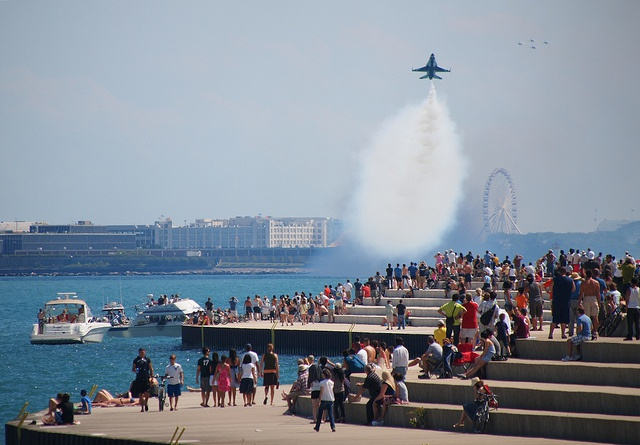Describe the objects in this image and their specific colors. I can see people in darkgray, black, gray, and maroon tones, boat in darkgray, gray, lightgray, and black tones, boat in darkgray, blue, white, and gray tones, people in darkgray, black, maroon, navy, and gray tones, and people in darkgray, black, and gray tones in this image. 